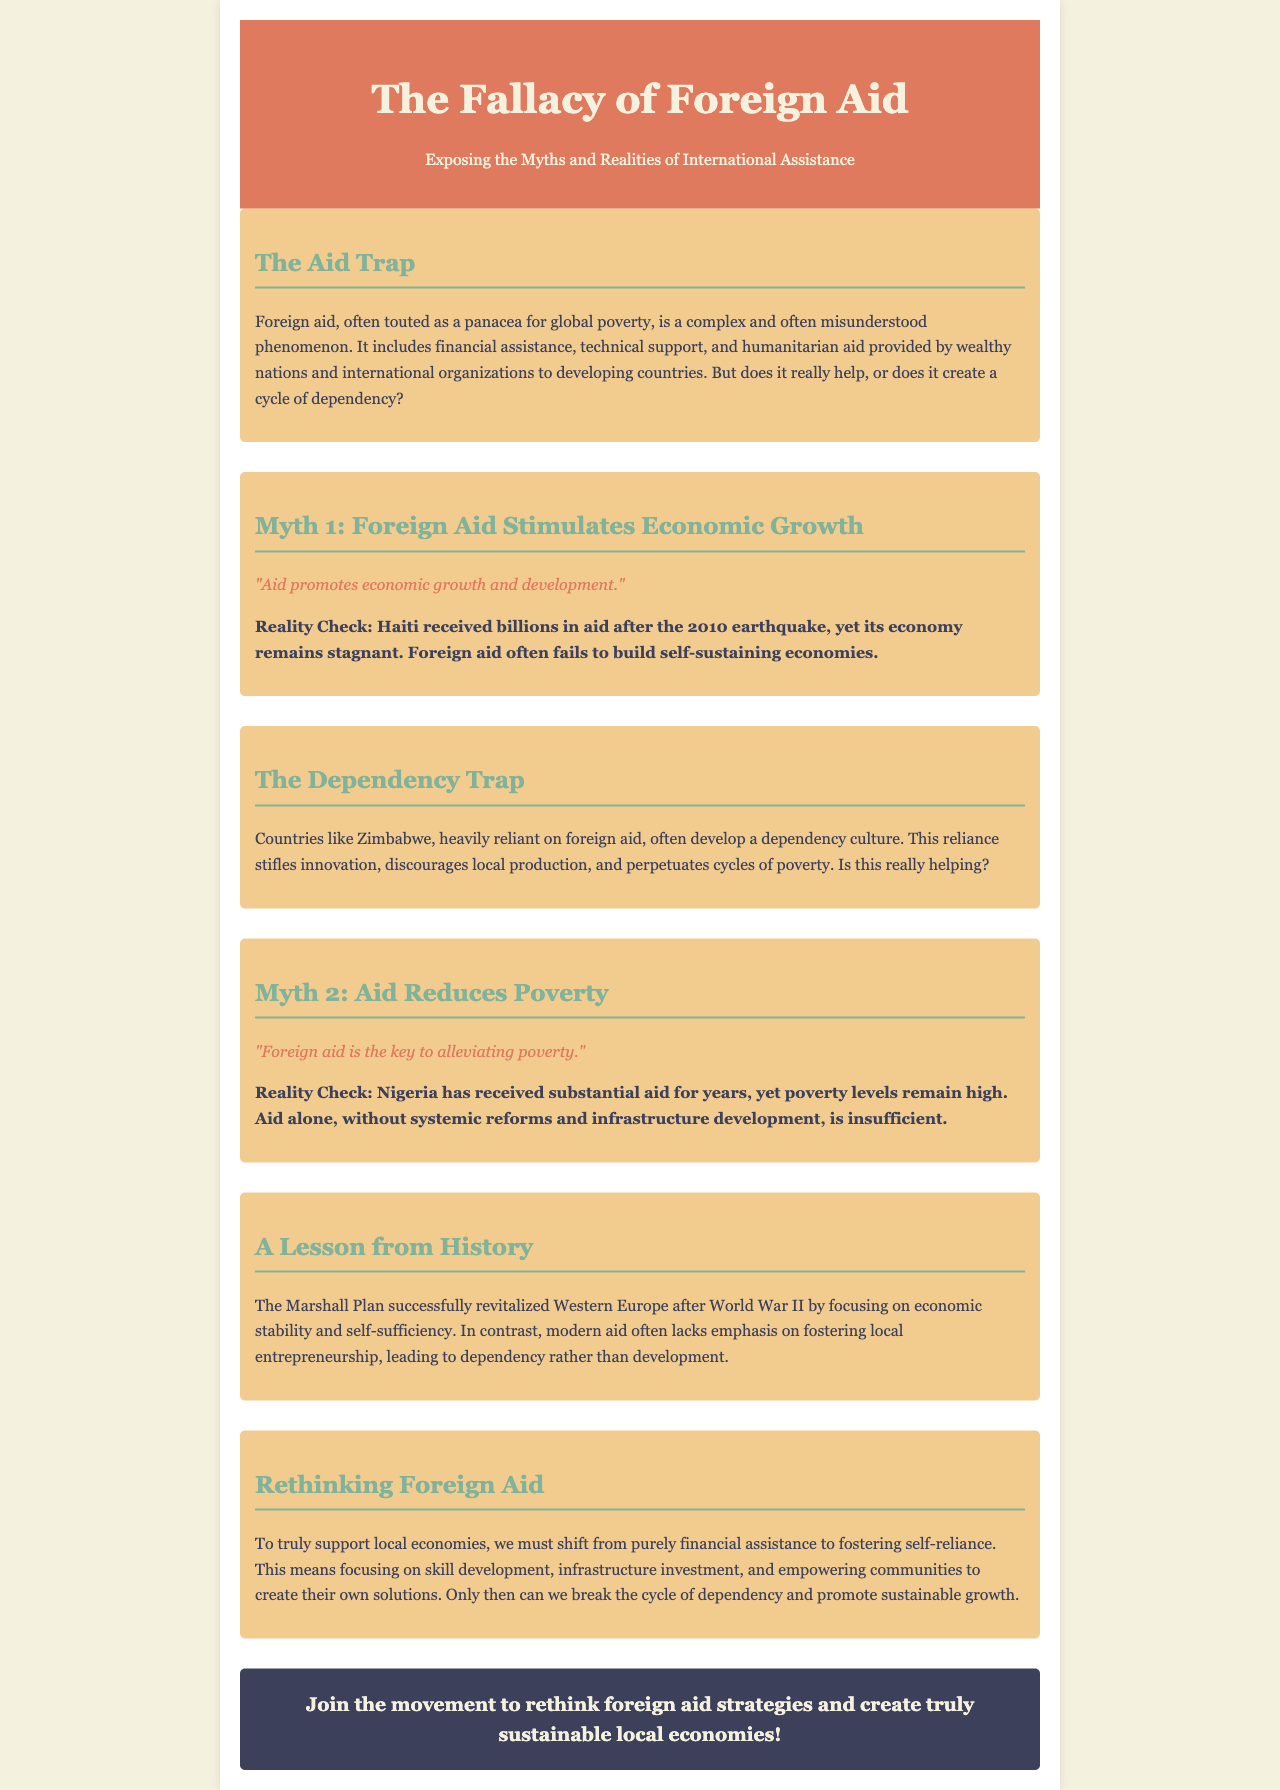What is the title of the brochure? The title is prominently displayed at the top of the document, stating the main theme of the content.
Answer: The Fallacy of Foreign Aid What year did Haiti receive billions in aid? The document mentions the event following the 2010 earthquake, which is when Haiti received substantial aid.
Answer: 2010 Which country is cited as an example of dependency in the document? Zimbabwe is specifically mentioned as a country that has developed a dependency culture due to reliance on foreign aid.
Answer: Zimbabwe What is the focus of the Marshall Plan according to the document? The document states that the Marshall Plan aimed to revitalize Western Europe with a focus on specific principles.
Answer: Economic stability and self-sufficiency What does the brochure suggest should be prioritized over financial assistance? The document advises a shift towards a different approach that fosters local economies through specific means.
Answer: Fostering self-reliance What does the phrase "dependency culture" refer to in the brochure? This term is used in the context of countries that rely heavily on foreign aid, impacting their innovation and production.
Answer: A reliance on foreign aid What does the document propose as a solution to break the cycle of dependency? The conclusion of the brochure gives insight into what actions should be taken to empower local communities.
Answer: Skill development, infrastructure investment, and empowering communities 